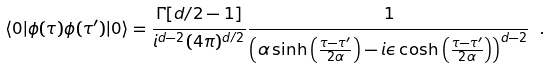<formula> <loc_0><loc_0><loc_500><loc_500>\langle { 0 } | \phi ( \tau ) \phi ( \tau ^ { \prime } ) | 0 \rangle = \frac { \Gamma [ d / 2 - 1 ] } { i ^ { d - 2 } ( 4 \pi ) ^ { d / 2 } } \frac { 1 } { \left ( \alpha \sinh \left ( \frac { \tau - \tau ^ { \prime } } { 2 \alpha } \right ) - i \epsilon \cosh \left ( \frac { \tau - \tau ^ { \prime } } { 2 \alpha } \right ) \right ) ^ { d - 2 } } \ .</formula> 